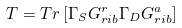<formula> <loc_0><loc_0><loc_500><loc_500>T = { T r } \left [ \Gamma _ { S } G _ { r i b } ^ { r } \Gamma _ { D } G _ { r i b } ^ { a } \right ]</formula> 